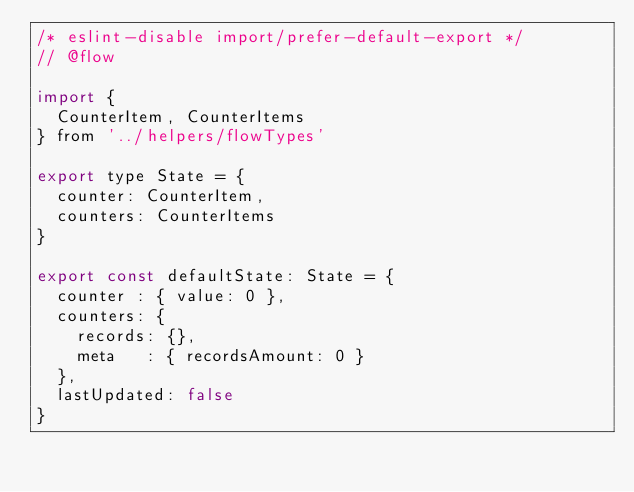<code> <loc_0><loc_0><loc_500><loc_500><_JavaScript_>/* eslint-disable import/prefer-default-export */
// @flow

import {
  CounterItem, CounterItems
} from '../helpers/flowTypes'

export type State = {
  counter: CounterItem,
  counters: CounterItems
}

export const defaultState: State = {
  counter : { value: 0 },
  counters: {
    records: {},
    meta   : { recordsAmount: 0 }
  },
  lastUpdated: false
}
</code> 